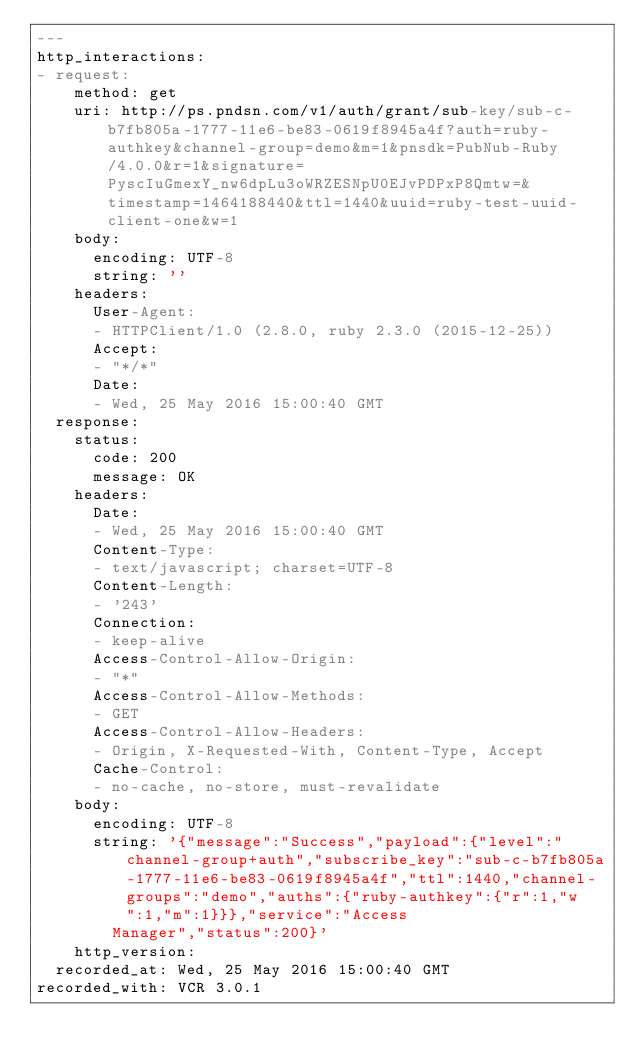Convert code to text. <code><loc_0><loc_0><loc_500><loc_500><_YAML_>---
http_interactions:
- request:
    method: get
    uri: http://ps.pndsn.com/v1/auth/grant/sub-key/sub-c-b7fb805a-1777-11e6-be83-0619f8945a4f?auth=ruby-authkey&channel-group=demo&m=1&pnsdk=PubNub-Ruby/4.0.0&r=1&signature=PyscIuGmexY_nw6dpLu3oWRZESNpU0EJvPDPxP8Qmtw=&timestamp=1464188440&ttl=1440&uuid=ruby-test-uuid-client-one&w=1
    body:
      encoding: UTF-8
      string: ''
    headers:
      User-Agent:
      - HTTPClient/1.0 (2.8.0, ruby 2.3.0 (2015-12-25))
      Accept:
      - "*/*"
      Date:
      - Wed, 25 May 2016 15:00:40 GMT
  response:
    status:
      code: 200
      message: OK
    headers:
      Date:
      - Wed, 25 May 2016 15:00:40 GMT
      Content-Type:
      - text/javascript; charset=UTF-8
      Content-Length:
      - '243'
      Connection:
      - keep-alive
      Access-Control-Allow-Origin:
      - "*"
      Access-Control-Allow-Methods:
      - GET
      Access-Control-Allow-Headers:
      - Origin, X-Requested-With, Content-Type, Accept
      Cache-Control:
      - no-cache, no-store, must-revalidate
    body:
      encoding: UTF-8
      string: '{"message":"Success","payload":{"level":"channel-group+auth","subscribe_key":"sub-c-b7fb805a-1777-11e6-be83-0619f8945a4f","ttl":1440,"channel-groups":"demo","auths":{"ruby-authkey":{"r":1,"w":1,"m":1}}},"service":"Access
        Manager","status":200}'
    http_version: 
  recorded_at: Wed, 25 May 2016 15:00:40 GMT
recorded_with: VCR 3.0.1
</code> 